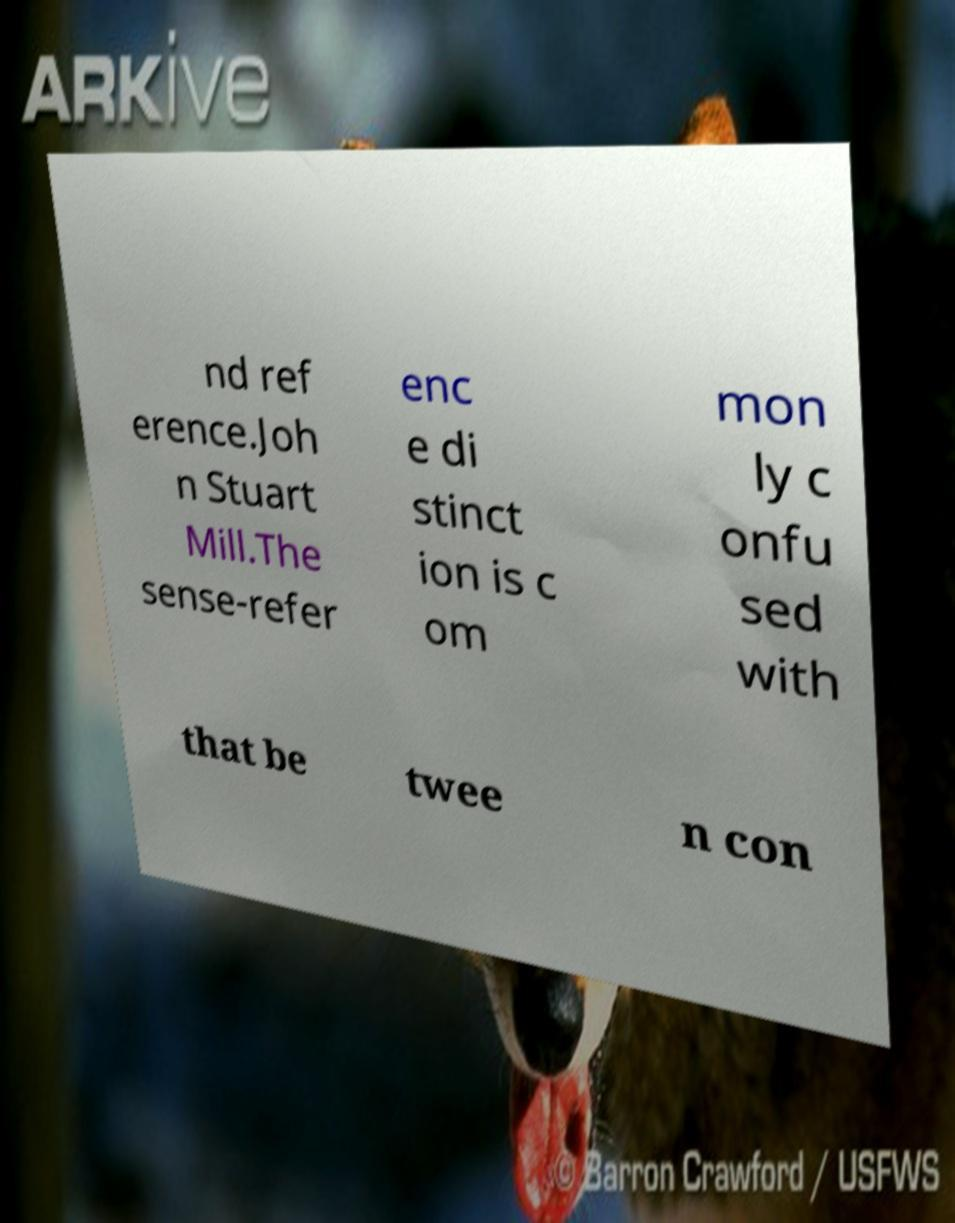Can you read and provide the text displayed in the image?This photo seems to have some interesting text. Can you extract and type it out for me? nd ref erence.Joh n Stuart Mill.The sense-refer enc e di stinct ion is c om mon ly c onfu sed with that be twee n con 